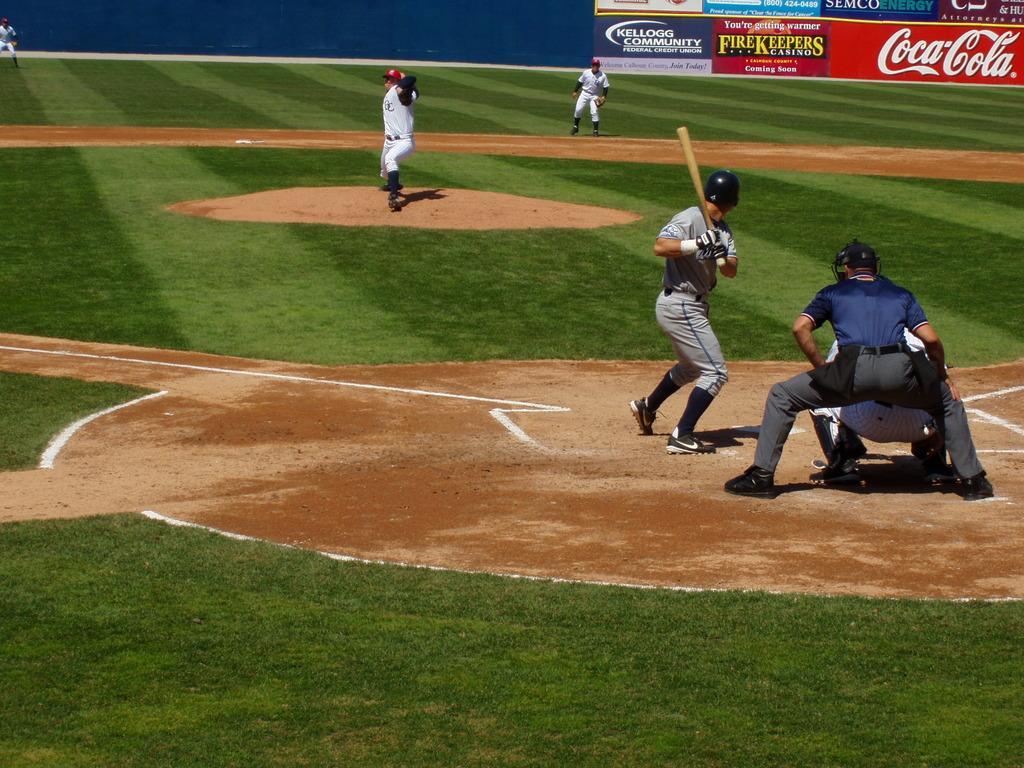How would you summarize this image in a sentence or two? This picture is taken in the ground. Towards the right, there is a man holding a bat. He is wearing grey clothes and black helmet. Beside him, there are two men is in squatting position. At the bottom, there is a grass. At the top, there are two people wearing white clothes. Behind them, there is a board with some text. 